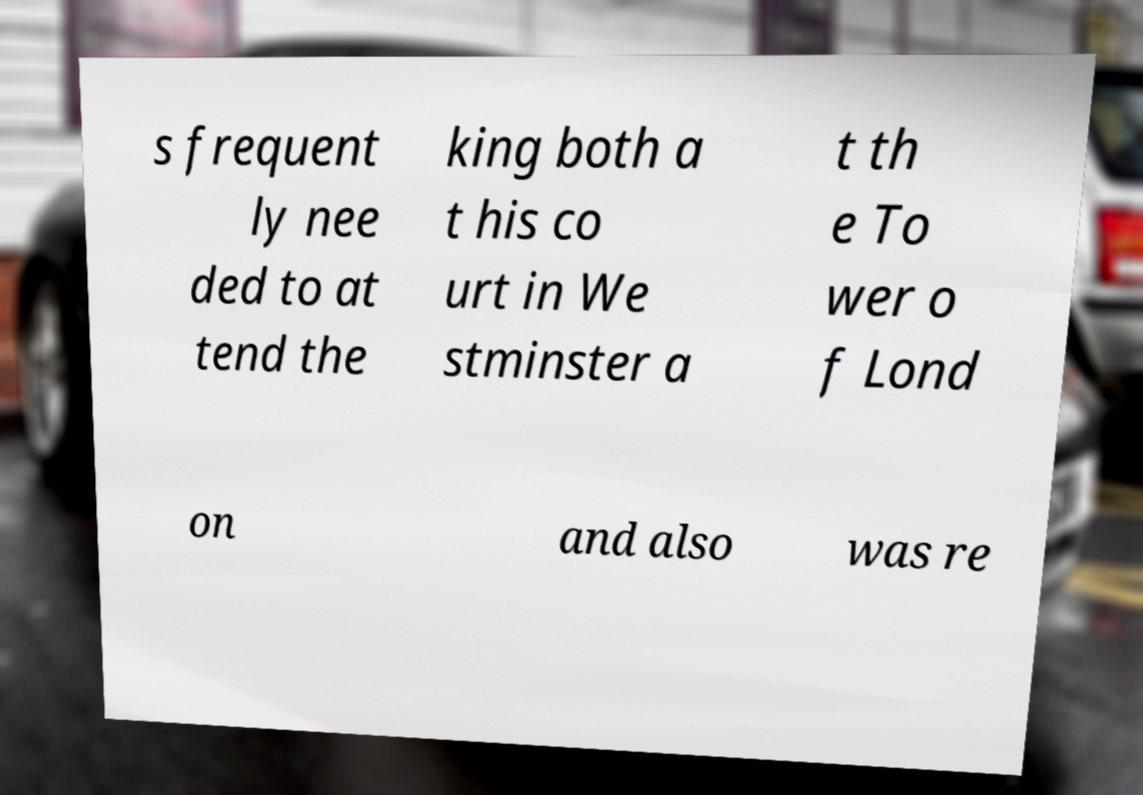Please identify and transcribe the text found in this image. s frequent ly nee ded to at tend the king both a t his co urt in We stminster a t th e To wer o f Lond on and also was re 